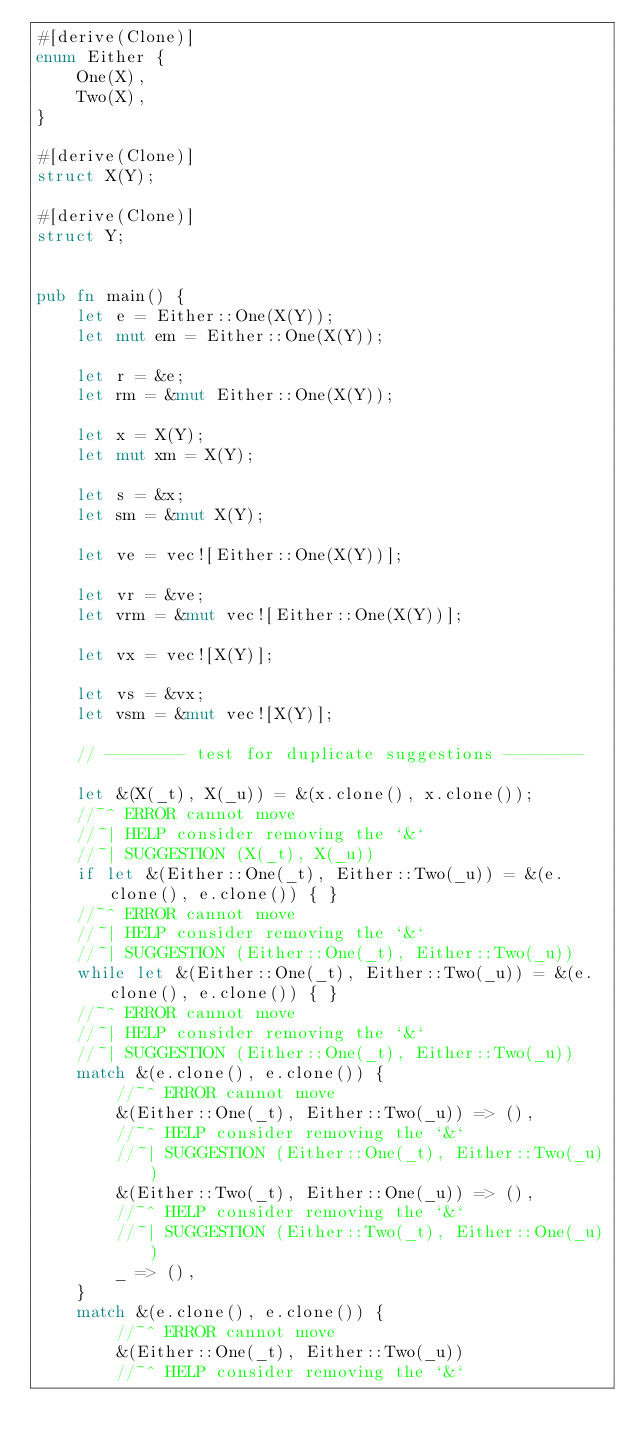<code> <loc_0><loc_0><loc_500><loc_500><_Rust_>#[derive(Clone)]
enum Either {
    One(X),
    Two(X),
}

#[derive(Clone)]
struct X(Y);

#[derive(Clone)]
struct Y;


pub fn main() {
    let e = Either::One(X(Y));
    let mut em = Either::One(X(Y));

    let r = &e;
    let rm = &mut Either::One(X(Y));

    let x = X(Y);
    let mut xm = X(Y);

    let s = &x;
    let sm = &mut X(Y);

    let ve = vec![Either::One(X(Y))];

    let vr = &ve;
    let vrm = &mut vec![Either::One(X(Y))];

    let vx = vec![X(Y)];

    let vs = &vx;
    let vsm = &mut vec![X(Y)];

    // -------- test for duplicate suggestions --------

    let &(X(_t), X(_u)) = &(x.clone(), x.clone());
    //~^ ERROR cannot move
    //~| HELP consider removing the `&`
    //~| SUGGESTION (X(_t), X(_u))
    if let &(Either::One(_t), Either::Two(_u)) = &(e.clone(), e.clone()) { }
    //~^ ERROR cannot move
    //~| HELP consider removing the `&`
    //~| SUGGESTION (Either::One(_t), Either::Two(_u))
    while let &(Either::One(_t), Either::Two(_u)) = &(e.clone(), e.clone()) { }
    //~^ ERROR cannot move
    //~| HELP consider removing the `&`
    //~| SUGGESTION (Either::One(_t), Either::Two(_u))
    match &(e.clone(), e.clone()) {
        //~^ ERROR cannot move
        &(Either::One(_t), Either::Two(_u)) => (),
        //~^ HELP consider removing the `&`
        //~| SUGGESTION (Either::One(_t), Either::Two(_u))
        &(Either::Two(_t), Either::One(_u)) => (),
        //~^ HELP consider removing the `&`
        //~| SUGGESTION (Either::Two(_t), Either::One(_u))
        _ => (),
    }
    match &(e.clone(), e.clone()) {
        //~^ ERROR cannot move
        &(Either::One(_t), Either::Two(_u))
        //~^ HELP consider removing the `&`</code> 